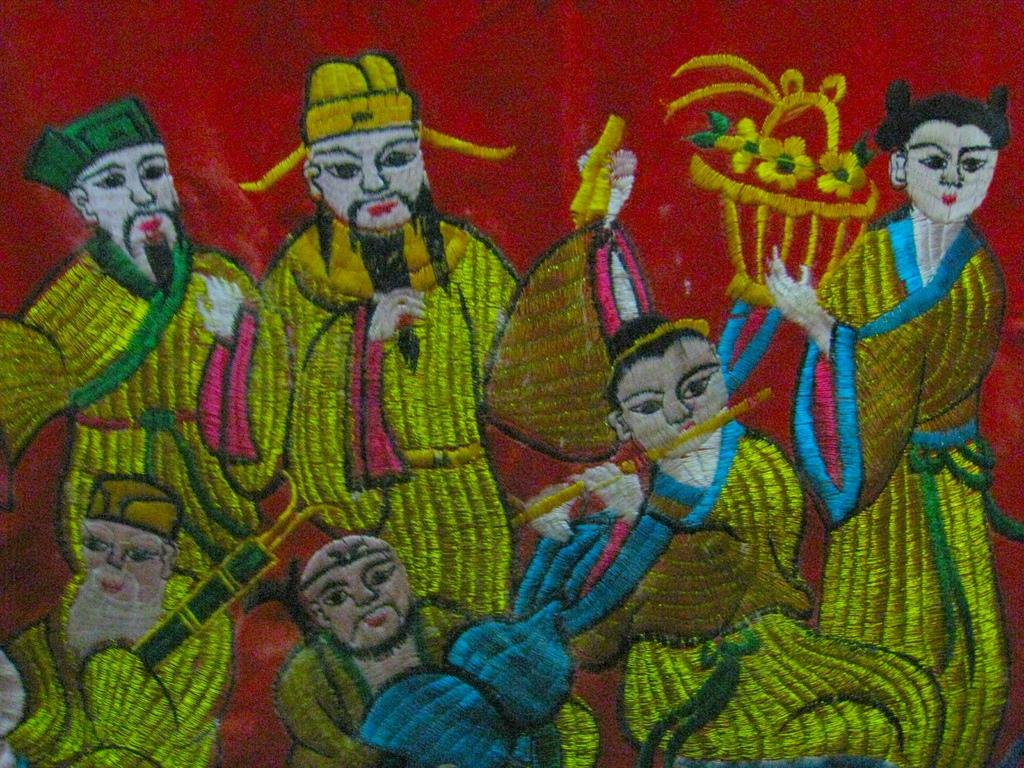What is depicted on the cloth in the image? There is an art of a group of people on a cloth. Can you describe the actions of any of the people in the image? One woman is holding a basket in her hand, and one person is holding a flute in his hands. What time is displayed on the clock in the image? There is no clock present in the image. How does the group of people in the image react to the woman's laugh? The text does not mention anyone laughing in the image. 